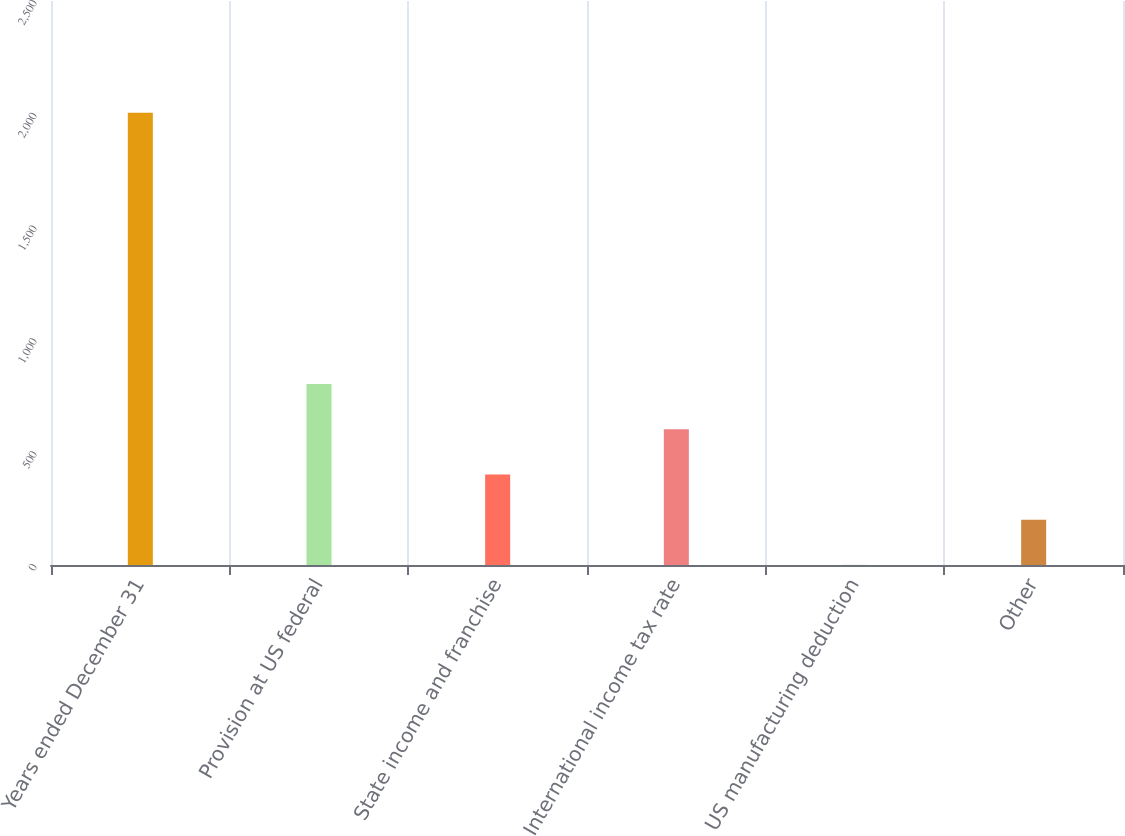Convert chart. <chart><loc_0><loc_0><loc_500><loc_500><bar_chart><fcel>Years ended December 31<fcel>Provision at US federal<fcel>State income and franchise<fcel>International income tax rate<fcel>US manufacturing deduction<fcel>Other<nl><fcel>2005<fcel>802.18<fcel>401.24<fcel>601.71<fcel>0.3<fcel>200.77<nl></chart> 